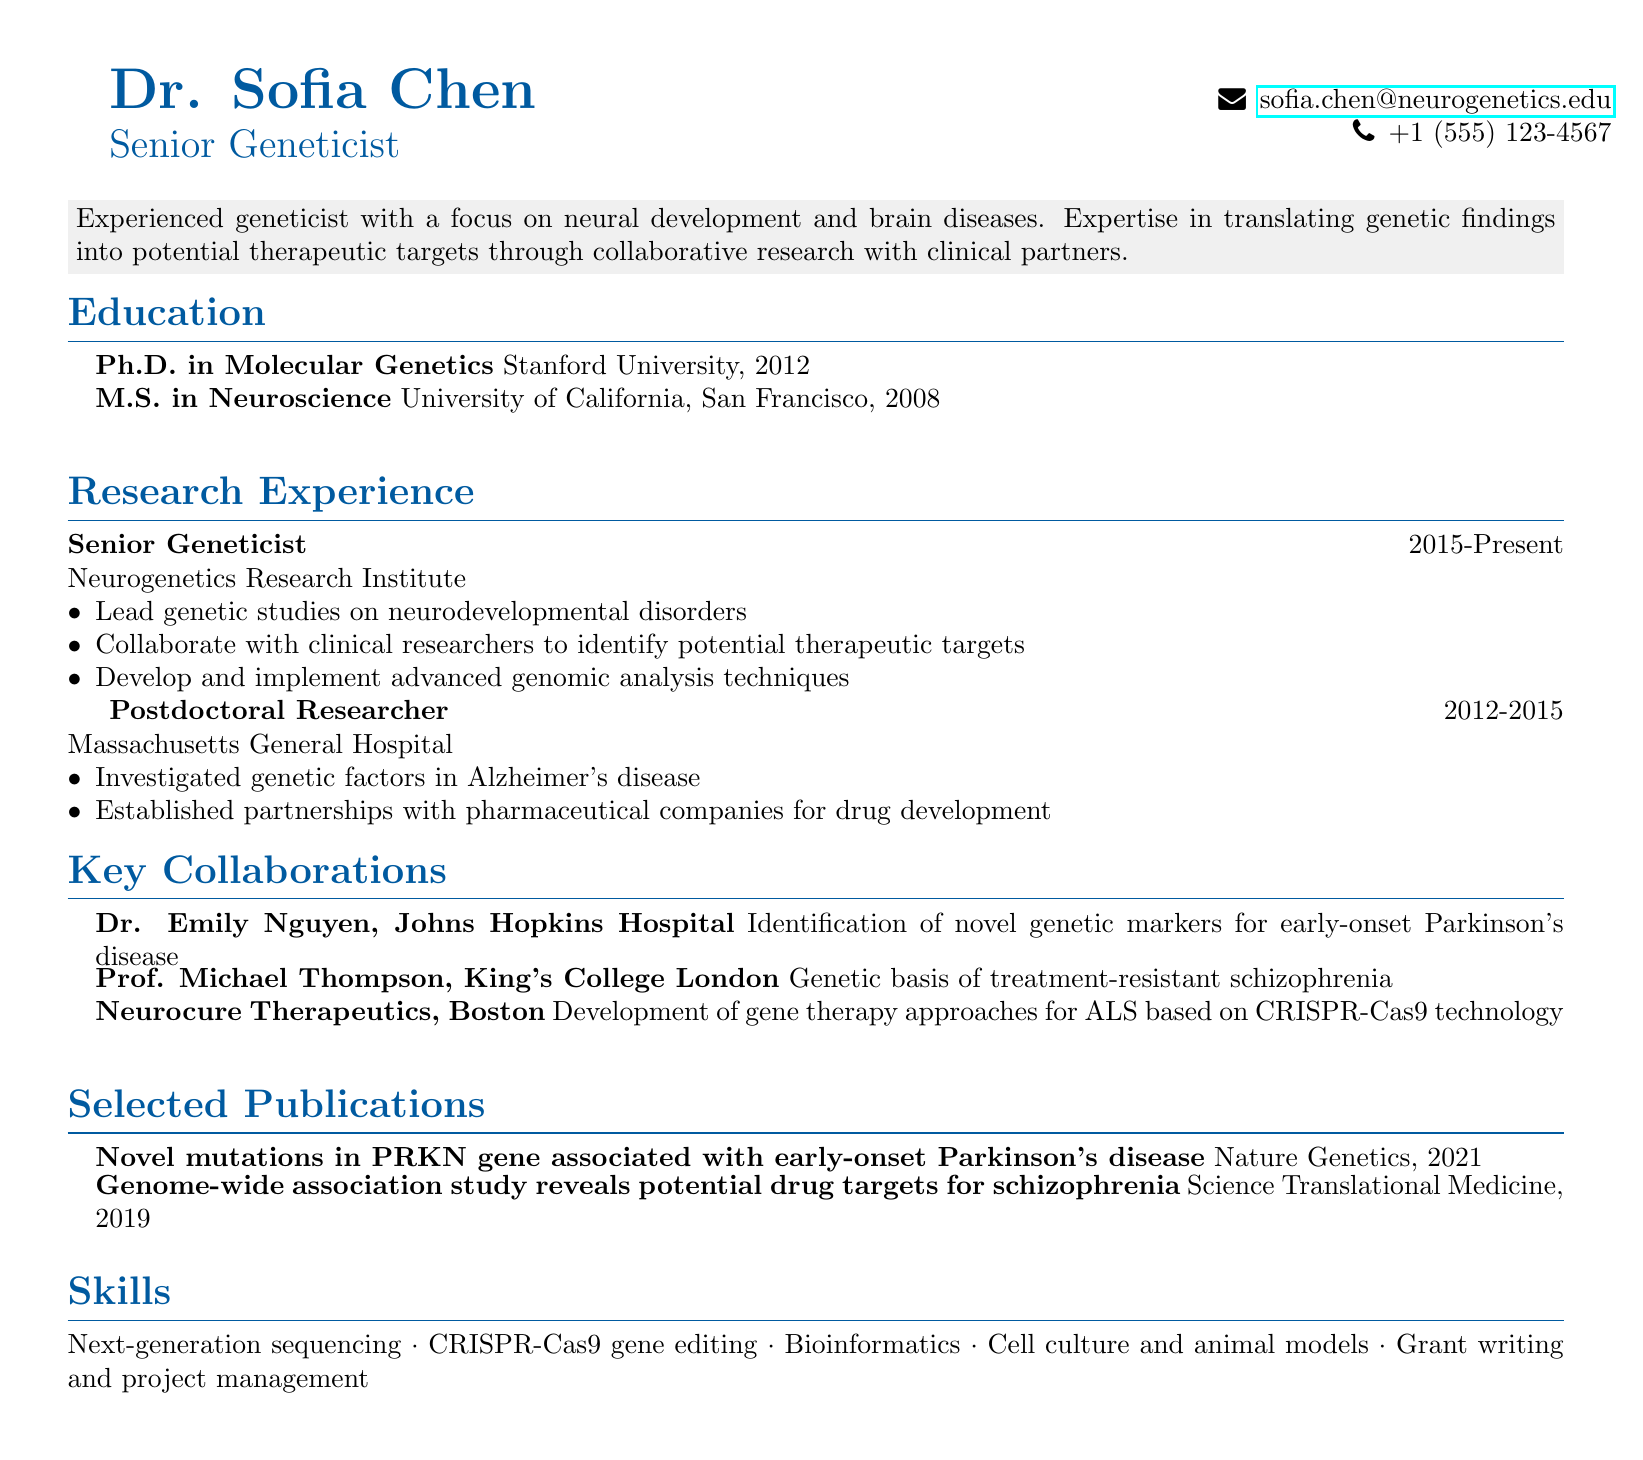What is the title of Dr. Sofia Chen? The title of Dr. Sofia Chen is listed prominently in the document.
Answer: Senior Geneticist What year did Dr. Sofia Chen complete her Ph.D.? Dr. Sofia Chen's educational background provides specific years of completion for her degrees.
Answer: 2012 What research position did Dr. Sofia Chen hold at the Massachusetts General Hospital? The document outlines Dr. Sofia Chen's previous research positions clearly.
Answer: Postdoctoral Researcher Which gene editing technology is mentioned in Dr. Chen's collaborations? The document describes the specific technology used in her collaborations.
Answer: CRISPR-Cas9 Who did Dr. Sofia Chen collaborate with on early-onset Parkinson's disease? This information is found in the key collaborations section of the document.
Answer: Dr. Emily Nguyen How many key collaborations are listed in the document? The document specifies multiple collaborations in a clear format.
Answer: Three What is a focus of Dr. Sofia Chen's research? The summary section provides insight into her research focus and expertise.
Answer: Neural development and brain diseases In which journal was the publication about early-onset Parkinson's disease published? The selected publications section includes corresponding journals for each paper.
Answer: Nature Genetics What is Dr. Sofia Chen's email address? Contact details are clearly presented in the document.
Answer: sofia.chen@neurogenetics.edu 